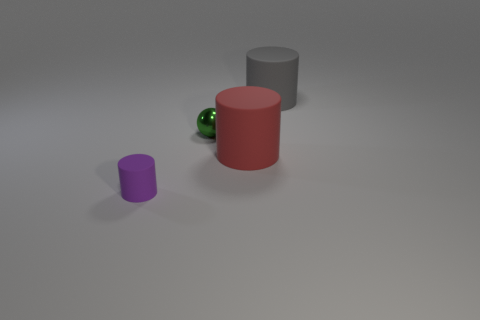How big is the thing that is both on the left side of the red rubber thing and in front of the tiny sphere?
Provide a succinct answer. Small. What number of gray rubber cylinders are in front of the big rubber cylinder in front of the tiny object that is right of the tiny matte thing?
Your response must be concise. 0. How many big things are either blue spheres or spheres?
Keep it short and to the point. 0. Is the material of the big thing that is in front of the big gray rubber thing the same as the tiny green object?
Provide a short and direct response. No. There is a large object that is on the right side of the big cylinder in front of the cylinder that is behind the small green metal object; what is its material?
Your response must be concise. Rubber. How many rubber things are big gray things or cylinders?
Make the answer very short. 3. Is there a small purple cylinder?
Give a very brief answer. Yes. There is a big cylinder that is on the left side of the large thing behind the small green shiny sphere; what is its color?
Your answer should be very brief. Red. How many other things are the same color as the small shiny object?
Ensure brevity in your answer.  0. What number of things are tiny cylinders or matte cylinders that are in front of the large red cylinder?
Keep it short and to the point. 1. 